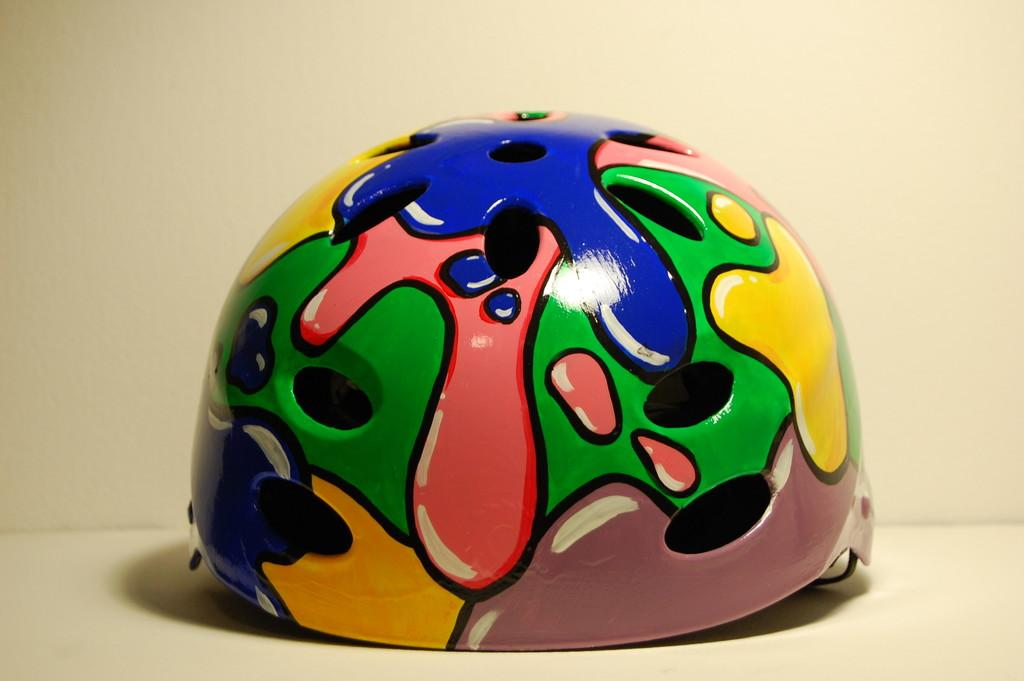What object can be seen on the floor in the image? There is a helmet on the floor in the image. Can you describe the position of the helmet in the image? The helmet is on the floor. How many rabbits are hiding in the stocking in the image? There are no rabbits or stockings present in the image; it only features a helmet on the floor. 